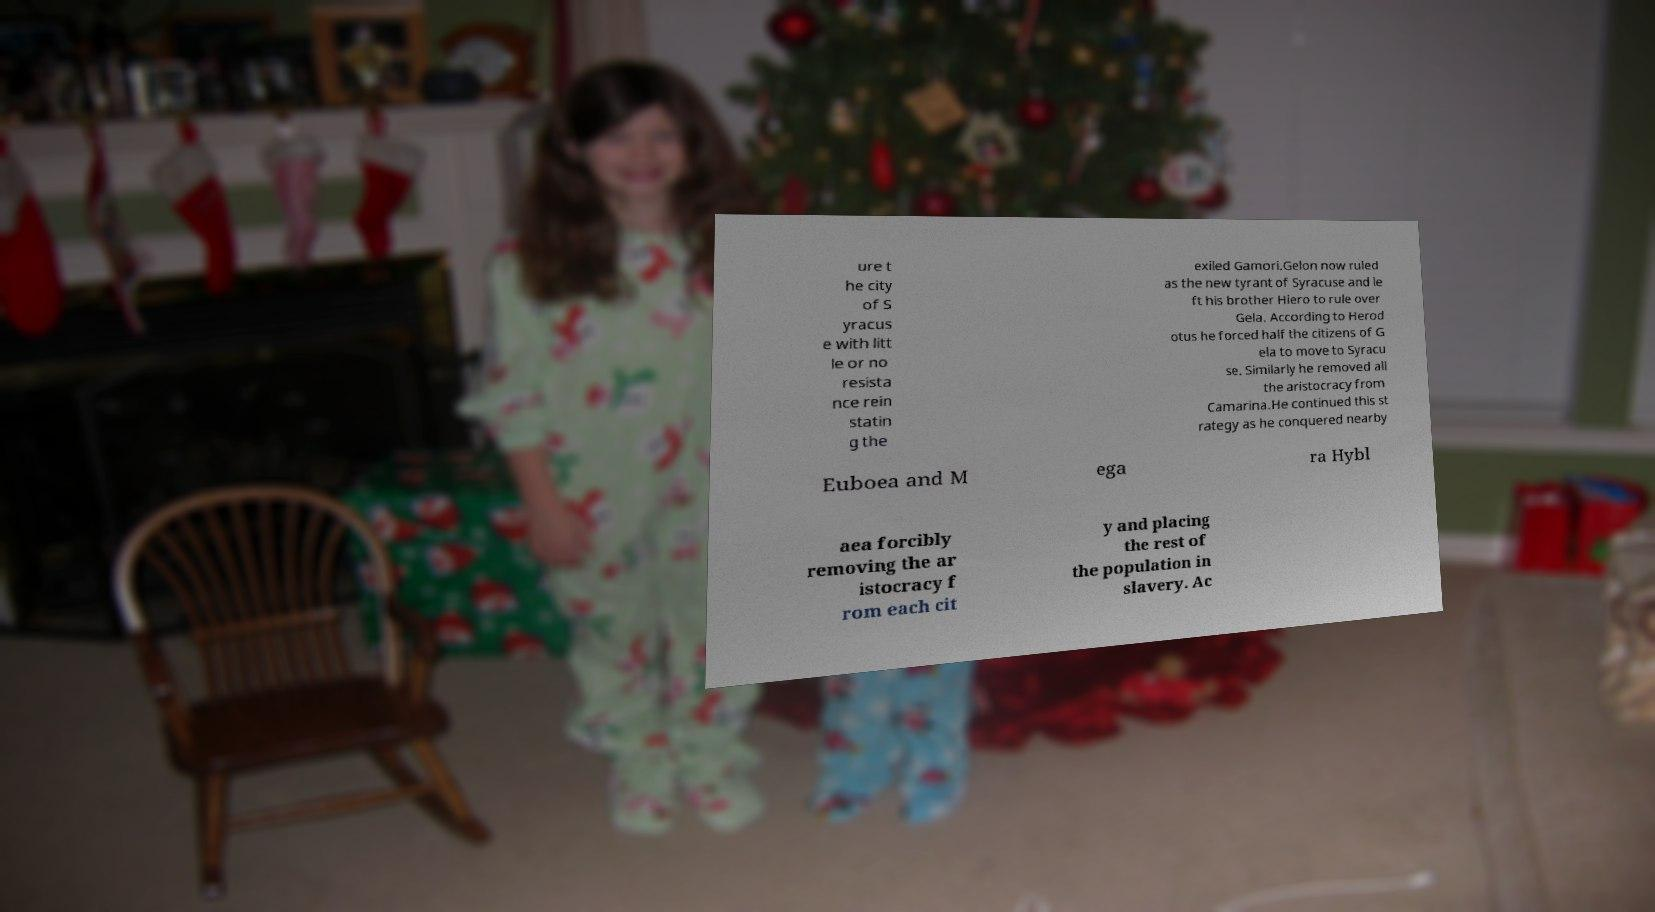Can you accurately transcribe the text from the provided image for me? ure t he city of S yracus e with litt le or no resista nce rein statin g the exiled Gamori.Gelon now ruled as the new tyrant of Syracuse and le ft his brother Hiero to rule over Gela. According to Herod otus he forced half the citizens of G ela to move to Syracu se. Similarly he removed all the aristocracy from Camarina.He continued this st rategy as he conquered nearby Euboea and M ega ra Hybl aea forcibly removing the ar istocracy f rom each cit y and placing the rest of the population in slavery. Ac 